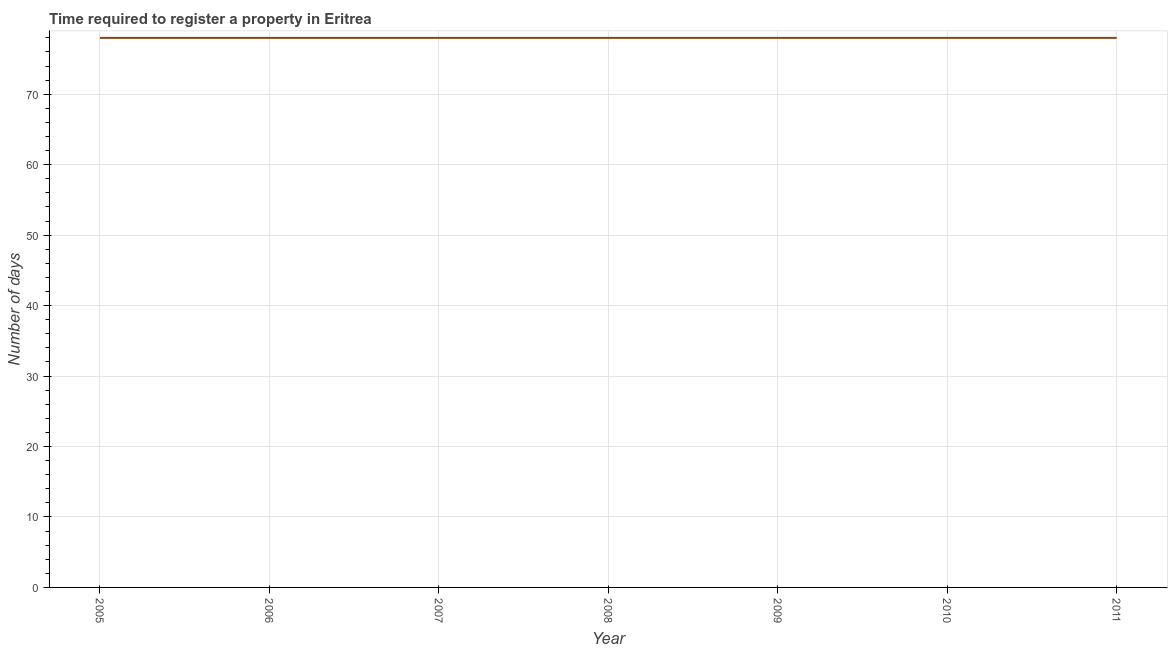What is the number of days required to register property in 2010?
Your answer should be compact. 78. Across all years, what is the maximum number of days required to register property?
Your response must be concise. 78. Across all years, what is the minimum number of days required to register property?
Your answer should be compact. 78. In which year was the number of days required to register property maximum?
Your response must be concise. 2005. In which year was the number of days required to register property minimum?
Ensure brevity in your answer.  2005. What is the sum of the number of days required to register property?
Offer a terse response. 546. What is the average number of days required to register property per year?
Your answer should be very brief. 78. In how many years, is the number of days required to register property greater than 70 days?
Make the answer very short. 7. Do a majority of the years between 2005 and 2007 (inclusive) have number of days required to register property greater than 26 days?
Make the answer very short. Yes. Is the number of days required to register property in 2005 less than that in 2008?
Keep it short and to the point. No. Is the difference between the number of days required to register property in 2007 and 2008 greater than the difference between any two years?
Your answer should be very brief. Yes. What is the difference between the highest and the second highest number of days required to register property?
Your answer should be very brief. 0. Is the sum of the number of days required to register property in 2009 and 2010 greater than the maximum number of days required to register property across all years?
Provide a succinct answer. Yes. What is the difference between the highest and the lowest number of days required to register property?
Your answer should be very brief. 0. In how many years, is the number of days required to register property greater than the average number of days required to register property taken over all years?
Ensure brevity in your answer.  0. What is the difference between two consecutive major ticks on the Y-axis?
Provide a short and direct response. 10. Does the graph contain any zero values?
Make the answer very short. No. What is the title of the graph?
Ensure brevity in your answer.  Time required to register a property in Eritrea. What is the label or title of the X-axis?
Your answer should be compact. Year. What is the label or title of the Y-axis?
Offer a very short reply. Number of days. What is the Number of days of 2007?
Offer a very short reply. 78. What is the Number of days in 2008?
Keep it short and to the point. 78. What is the Number of days in 2009?
Provide a succinct answer. 78. What is the Number of days in 2011?
Give a very brief answer. 78. What is the difference between the Number of days in 2005 and 2006?
Your answer should be very brief. 0. What is the difference between the Number of days in 2006 and 2008?
Provide a succinct answer. 0. What is the difference between the Number of days in 2006 and 2009?
Your answer should be very brief. 0. What is the difference between the Number of days in 2007 and 2009?
Provide a short and direct response. 0. What is the difference between the Number of days in 2008 and 2009?
Your answer should be very brief. 0. What is the difference between the Number of days in 2008 and 2010?
Your response must be concise. 0. What is the difference between the Number of days in 2008 and 2011?
Provide a short and direct response. 0. What is the difference between the Number of days in 2009 and 2010?
Offer a terse response. 0. What is the difference between the Number of days in 2009 and 2011?
Provide a succinct answer. 0. What is the ratio of the Number of days in 2005 to that in 2006?
Keep it short and to the point. 1. What is the ratio of the Number of days in 2005 to that in 2007?
Your response must be concise. 1. What is the ratio of the Number of days in 2005 to that in 2008?
Give a very brief answer. 1. What is the ratio of the Number of days in 2005 to that in 2009?
Make the answer very short. 1. What is the ratio of the Number of days in 2005 to that in 2011?
Offer a very short reply. 1. What is the ratio of the Number of days in 2006 to that in 2008?
Give a very brief answer. 1. What is the ratio of the Number of days in 2006 to that in 2009?
Your response must be concise. 1. What is the ratio of the Number of days in 2007 to that in 2008?
Your answer should be compact. 1. What is the ratio of the Number of days in 2007 to that in 2009?
Make the answer very short. 1. What is the ratio of the Number of days in 2007 to that in 2010?
Give a very brief answer. 1. What is the ratio of the Number of days in 2008 to that in 2010?
Ensure brevity in your answer.  1. What is the ratio of the Number of days in 2008 to that in 2011?
Your response must be concise. 1. 